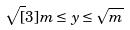Convert formula to latex. <formula><loc_0><loc_0><loc_500><loc_500>\sqrt { [ } 3 ] { m } \leq y \leq \sqrt { m }</formula> 